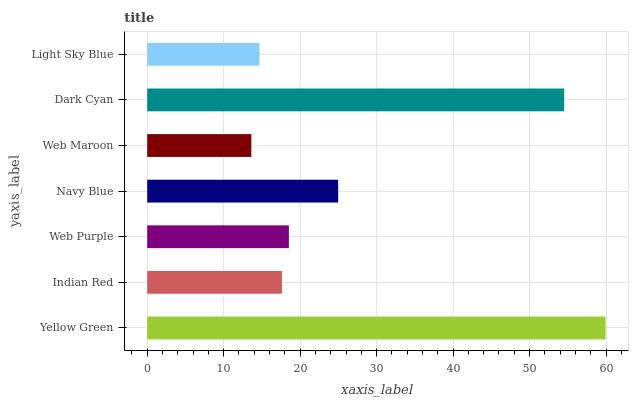Is Web Maroon the minimum?
Answer yes or no. Yes. Is Yellow Green the maximum?
Answer yes or no. Yes. Is Indian Red the minimum?
Answer yes or no. No. Is Indian Red the maximum?
Answer yes or no. No. Is Yellow Green greater than Indian Red?
Answer yes or no. Yes. Is Indian Red less than Yellow Green?
Answer yes or no. Yes. Is Indian Red greater than Yellow Green?
Answer yes or no. No. Is Yellow Green less than Indian Red?
Answer yes or no. No. Is Web Purple the high median?
Answer yes or no. Yes. Is Web Purple the low median?
Answer yes or no. Yes. Is Yellow Green the high median?
Answer yes or no. No. Is Navy Blue the low median?
Answer yes or no. No. 